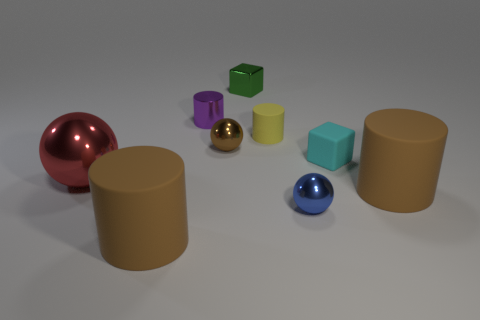What number of objects are brown matte blocks or tiny things behind the big red sphere?
Offer a very short reply. 5. There is a brown rubber cylinder to the right of the yellow matte thing; does it have the same size as the tiny purple thing?
Make the answer very short. No. How many other objects are there of the same shape as the green metal thing?
Offer a terse response. 1. What number of blue things are either matte objects or small metal balls?
Ensure brevity in your answer.  1. There is a big rubber cylinder right of the blue metallic sphere; does it have the same color as the rubber cube?
Provide a short and direct response. No. What is the shape of the small object that is the same material as the tiny cyan cube?
Provide a succinct answer. Cylinder. The ball that is both in front of the brown sphere and to the left of the small green shiny cube is what color?
Give a very brief answer. Red. What is the size of the brown matte cylinder that is in front of the brown thing that is to the right of the blue object?
Provide a succinct answer. Large. Is the number of objects that are behind the blue object the same as the number of big brown matte things?
Make the answer very short. No. How many shiny things are there?
Provide a succinct answer. 5. 